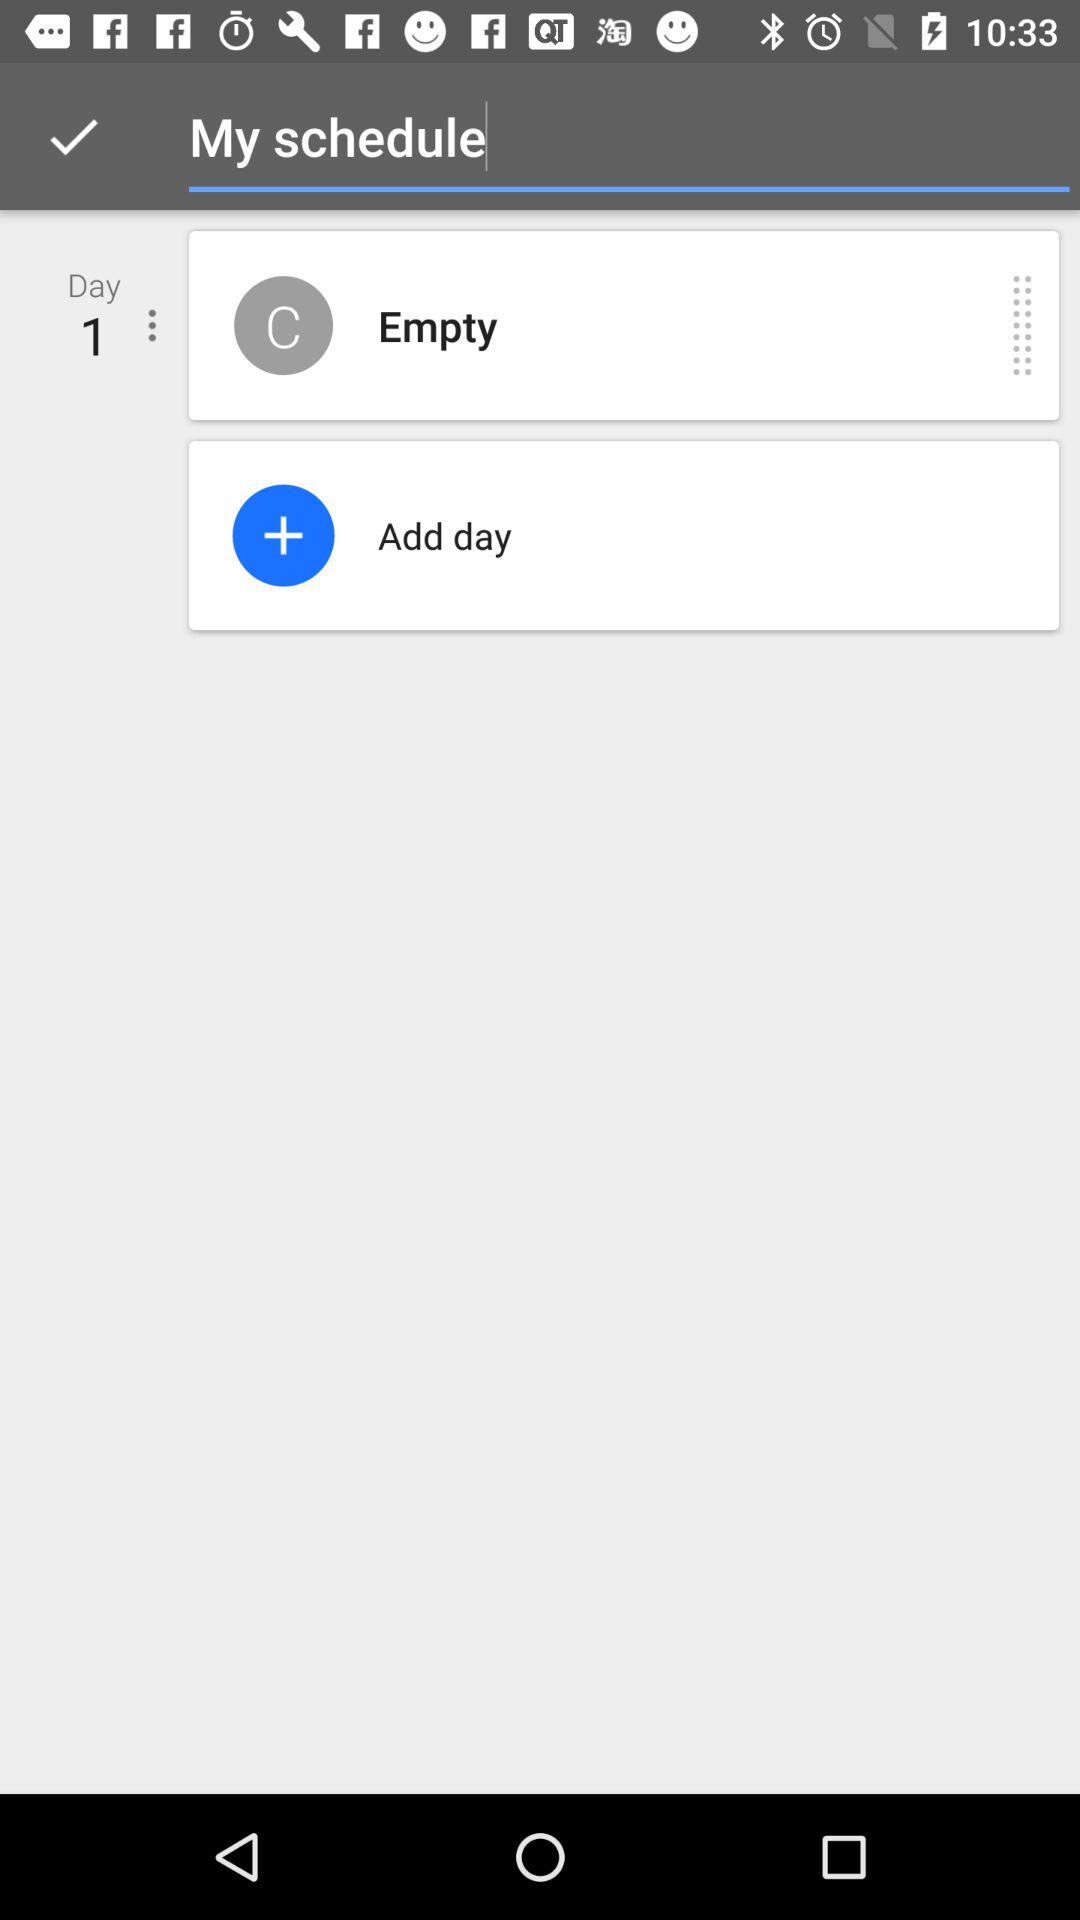What day is mentioned? The mentioned day is 1. 